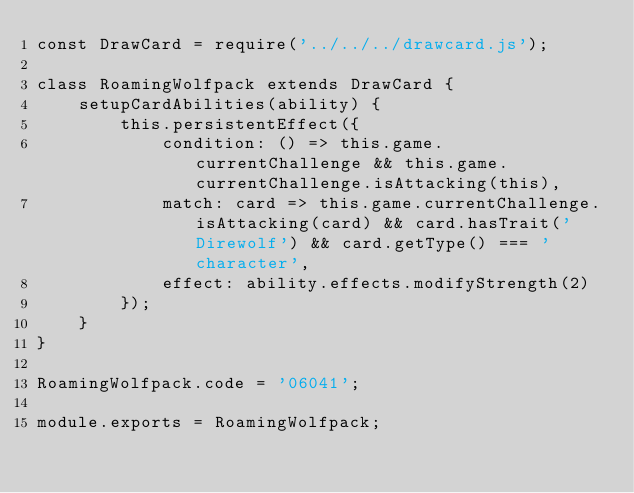Convert code to text. <code><loc_0><loc_0><loc_500><loc_500><_JavaScript_>const DrawCard = require('../../../drawcard.js');

class RoamingWolfpack extends DrawCard {
    setupCardAbilities(ability) {
        this.persistentEffect({
            condition: () => this.game.currentChallenge && this.game.currentChallenge.isAttacking(this),
            match: card => this.game.currentChallenge.isAttacking(card) && card.hasTrait('Direwolf') && card.getType() === 'character',
            effect: ability.effects.modifyStrength(2)
        });
    }
}

RoamingWolfpack.code = '06041';

module.exports = RoamingWolfpack;
</code> 